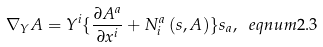<formula> <loc_0><loc_0><loc_500><loc_500>\nabla _ { Y } A = Y ^ { i } \{ \frac { \partial A ^ { a } } { \partial x ^ { i } } + N _ { i } ^ { a } \left ( s , A \right ) \} s _ { a } , \ e q n u m { 2 . 3 }</formula> 